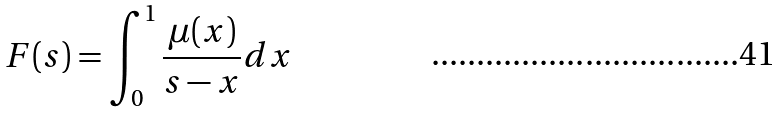<formula> <loc_0><loc_0><loc_500><loc_500>F ( s ) = \int _ { 0 } ^ { 1 } \frac { \mu ( x ) } { s - x } d x</formula> 